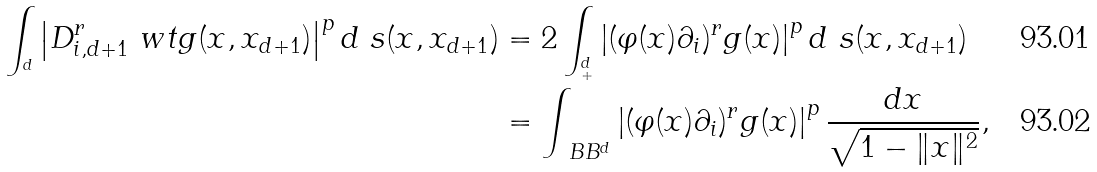<formula> <loc_0><loc_0><loc_500><loc_500>\int _ { ^ { d } } \left | D _ { i , d + 1 } ^ { r } \ w t g ( x , x _ { d + 1 } ) \right | ^ { p } d \ s ( x , x _ { d + 1 } ) & = 2 \int _ { ^ { d } _ { + } } \left | ( \varphi ( x ) \partial _ { i } ) ^ { r } g ( x ) \right | ^ { p } d \ s ( x , x _ { d + 1 } ) \\ & = \int _ { \ B B ^ { d } } \left | ( \varphi ( x ) \partial _ { i } ) ^ { r } g ( x ) \right | ^ { p } \frac { d x } { \sqrt { 1 - \| x \| ^ { 2 } } } ,</formula> 